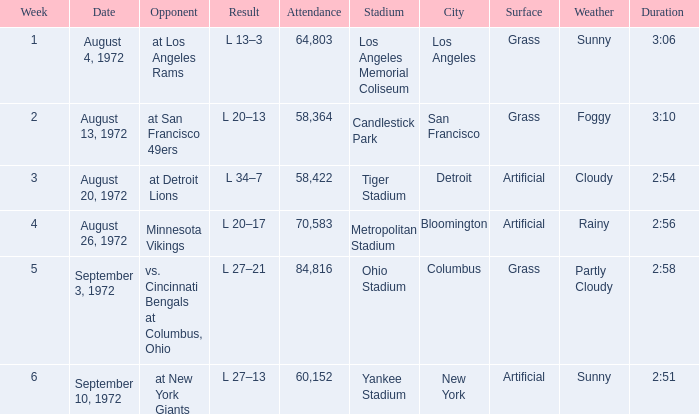What is the date of week 4? August 26, 1972. 